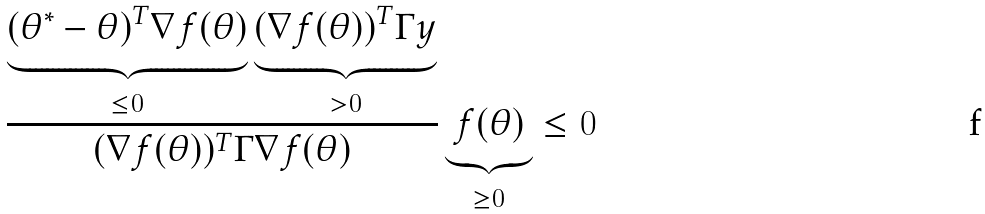<formula> <loc_0><loc_0><loc_500><loc_500>\frac { \underbrace { ( \theta ^ { * } - \theta ) ^ { T } \nabla f ( \theta ) } _ { \leq 0 } \underbrace { ( \nabla f ( \theta ) ) ^ { T } \Gamma y } _ { > 0 } } { ( \nabla f ( \theta ) ) ^ { T } \Gamma \nabla f ( \theta ) } \underbrace { f ( \theta ) } _ { \geq 0 } \leq 0</formula> 